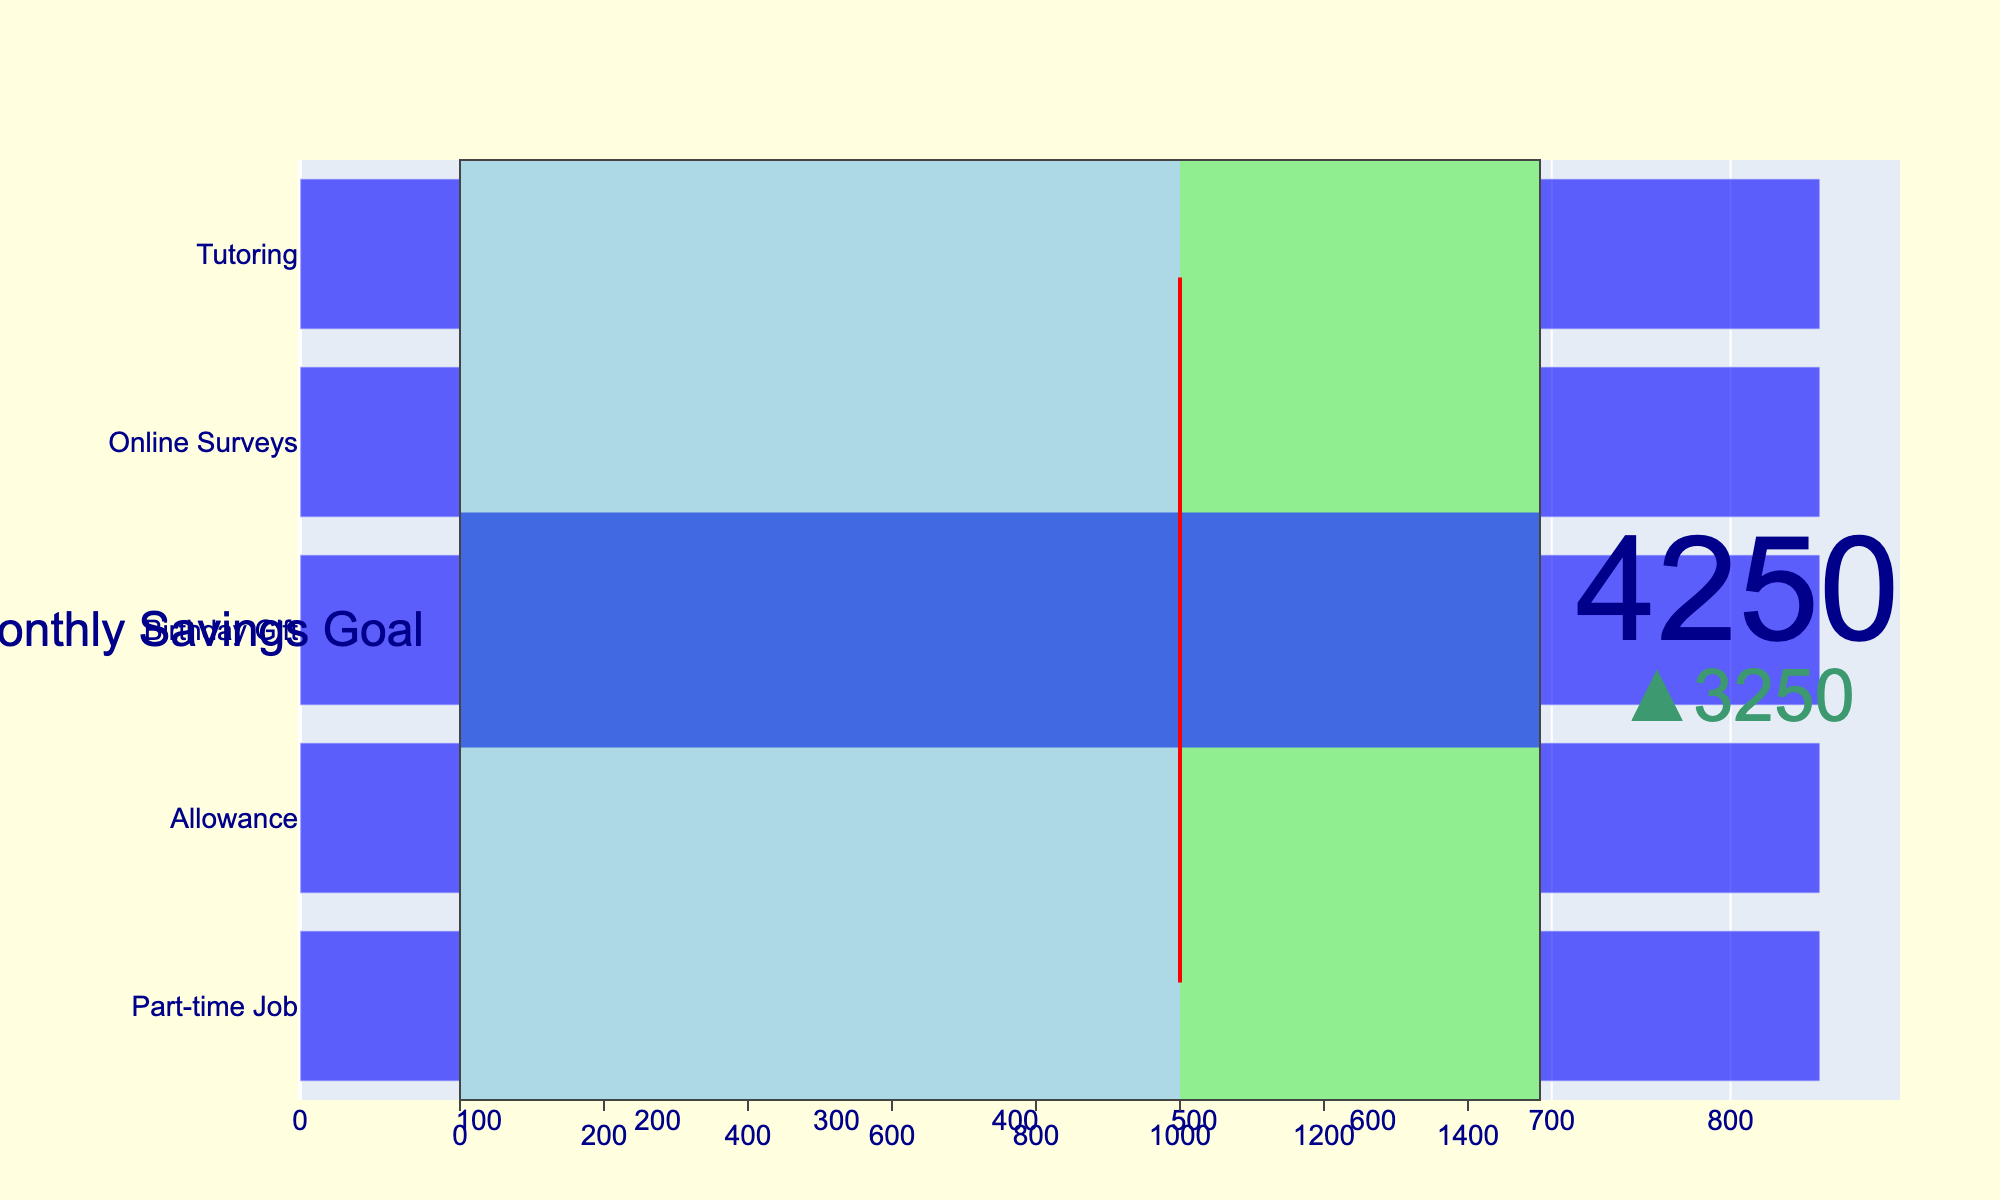What is the title of the chart? The title is displayed at the top of the chart, which indicates the main subject being represented.
Answer: Progress towards Monthly Savings Goal What is the target value for the monthly savings goal? The target value can be observed by looking at the specified threshold value, typically marked by a distinct visual indicator in the gauge.
Answer: 1000 How much have you actually saved towards your monthly goal? The actual saved amount is shown by the main indicator value in the chart.
Answer: 850 Which income source contributed the most to the saved amount? By comparing the lengths of the horizontal bars representing each income source, the source with the longest bar will be the highest contributor.
Answer: All sources contributed equally Is the actual savings value greater than, less than, or equal to the target value? By comparing the actual savings value with the marked target value on the bullet chart, we see that the actual savings value is less than the target.
Answer: Less than What is the color representing the savings range below the target? The part of the gauge below the target value is likely shaded in a specific color to indicate progress.
Answer: Light blue What income sources are represented in the chart? By examining the labels on the horizontal axis (y-axis) of the bullet chart, we can list all contributing income sources.
Answer: Part-time Job, Allowance, Birthday Gift, Online Surveys, Tutoring How does the actual savings amount compare to the maximum range displayed on the gauge? The gauge's maximum value is typically a multiple of the target value, and by comparing the actual savings to this range, one can determine its relative position.
Answer: Less than the maximum range Are the income sources visually distinguished by unique colors? Each bar representing different income sources may have unique colors to differentiate them visually.
Answer: No, all bars have the same color 